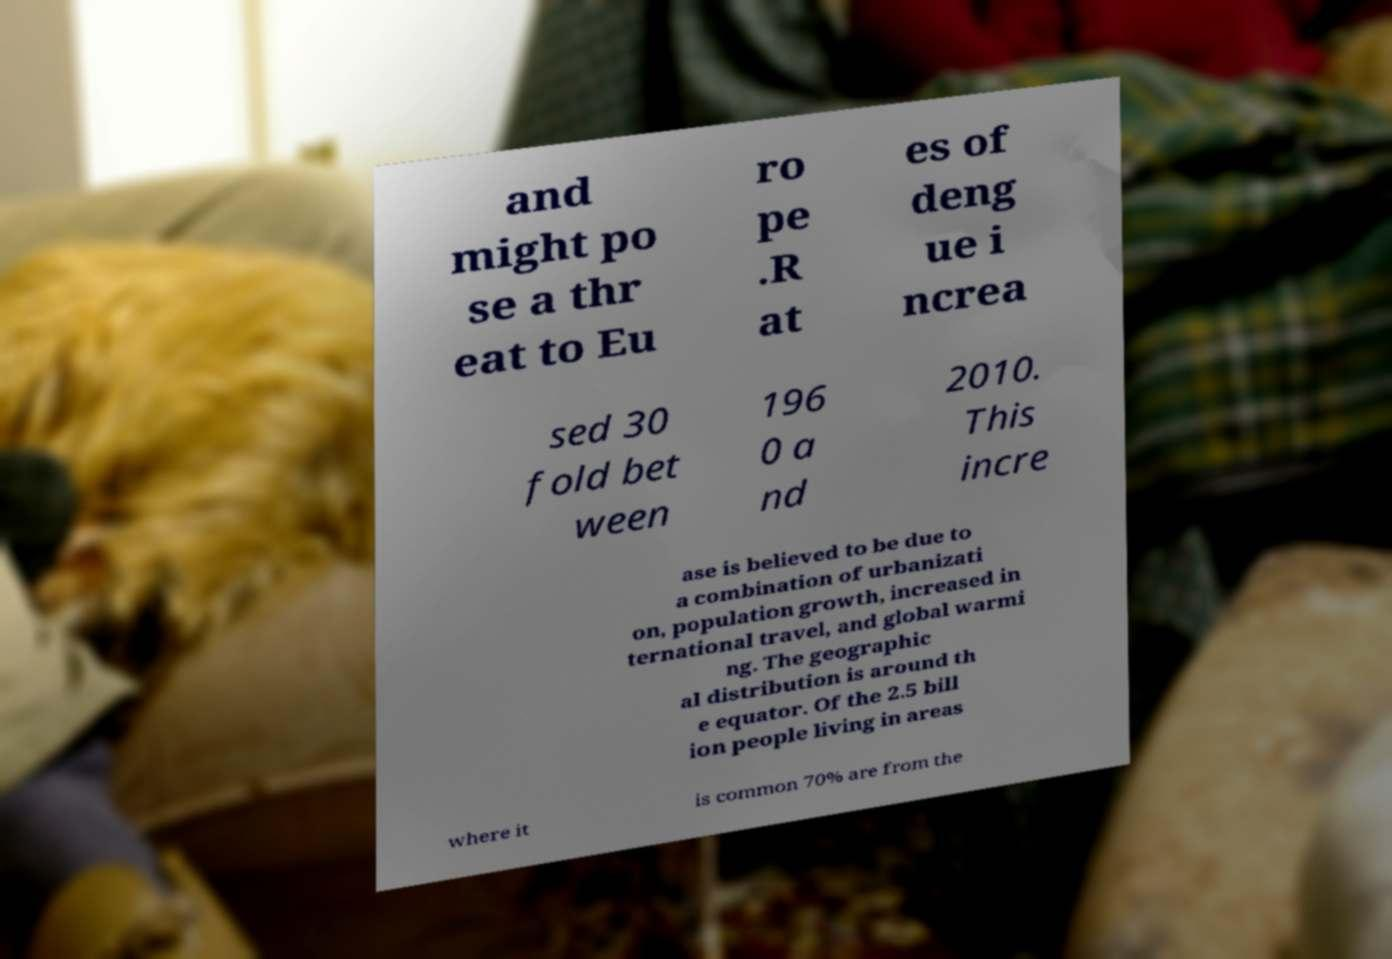There's text embedded in this image that I need extracted. Can you transcribe it verbatim? and might po se a thr eat to Eu ro pe .R at es of deng ue i ncrea sed 30 fold bet ween 196 0 a nd 2010. This incre ase is believed to be due to a combination of urbanizati on, population growth, increased in ternational travel, and global warmi ng. The geographic al distribution is around th e equator. Of the 2.5 bill ion people living in areas where it is common 70% are from the 